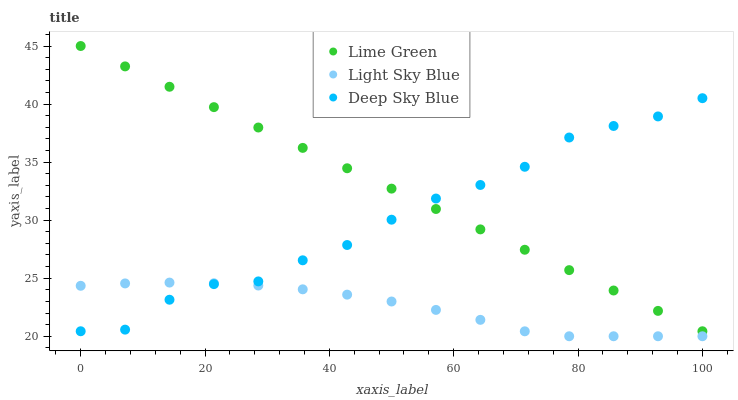Does Light Sky Blue have the minimum area under the curve?
Answer yes or no. Yes. Does Lime Green have the maximum area under the curve?
Answer yes or no. Yes. Does Deep Sky Blue have the minimum area under the curve?
Answer yes or no. No. Does Deep Sky Blue have the maximum area under the curve?
Answer yes or no. No. Is Lime Green the smoothest?
Answer yes or no. Yes. Is Deep Sky Blue the roughest?
Answer yes or no. Yes. Is Deep Sky Blue the smoothest?
Answer yes or no. No. Is Lime Green the roughest?
Answer yes or no. No. Does Light Sky Blue have the lowest value?
Answer yes or no. Yes. Does Lime Green have the lowest value?
Answer yes or no. No. Does Lime Green have the highest value?
Answer yes or no. Yes. Does Deep Sky Blue have the highest value?
Answer yes or no. No. Is Light Sky Blue less than Lime Green?
Answer yes or no. Yes. Is Lime Green greater than Light Sky Blue?
Answer yes or no. Yes. Does Lime Green intersect Deep Sky Blue?
Answer yes or no. Yes. Is Lime Green less than Deep Sky Blue?
Answer yes or no. No. Is Lime Green greater than Deep Sky Blue?
Answer yes or no. No. Does Light Sky Blue intersect Lime Green?
Answer yes or no. No. 